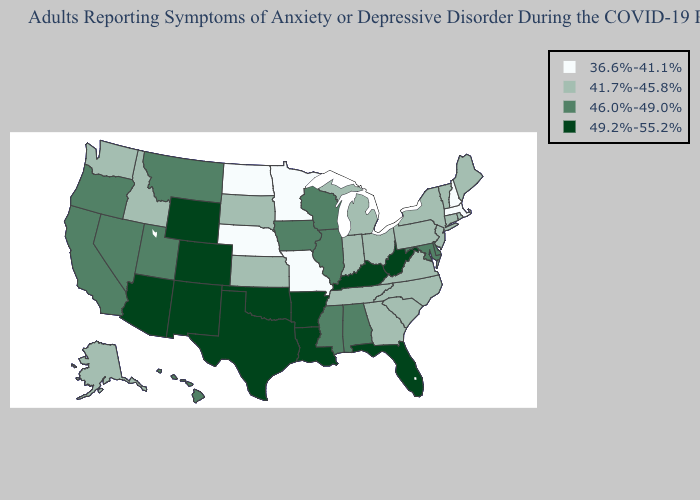Is the legend a continuous bar?
Keep it brief. No. Does Washington have the highest value in the West?
Concise answer only. No. Name the states that have a value in the range 41.7%-45.8%?
Give a very brief answer. Alaska, Connecticut, Georgia, Idaho, Indiana, Kansas, Maine, Michigan, New Jersey, New York, North Carolina, Ohio, Pennsylvania, Rhode Island, South Carolina, South Dakota, Tennessee, Vermont, Virginia, Washington. Does Maryland have the same value as Montana?
Answer briefly. Yes. Is the legend a continuous bar?
Write a very short answer. No. What is the value of Indiana?
Short answer required. 41.7%-45.8%. Among the states that border Colorado , does New Mexico have the lowest value?
Concise answer only. No. Name the states that have a value in the range 49.2%-55.2%?
Give a very brief answer. Arizona, Arkansas, Colorado, Florida, Kentucky, Louisiana, New Mexico, Oklahoma, Texas, West Virginia, Wyoming. What is the value of Ohio?
Write a very short answer. 41.7%-45.8%. Name the states that have a value in the range 49.2%-55.2%?
Answer briefly. Arizona, Arkansas, Colorado, Florida, Kentucky, Louisiana, New Mexico, Oklahoma, Texas, West Virginia, Wyoming. Among the states that border Oregon , does Washington have the lowest value?
Quick response, please. Yes. What is the value of Virginia?
Write a very short answer. 41.7%-45.8%. What is the value of West Virginia?
Answer briefly. 49.2%-55.2%. Does Oregon have a lower value than Texas?
Keep it brief. Yes. 